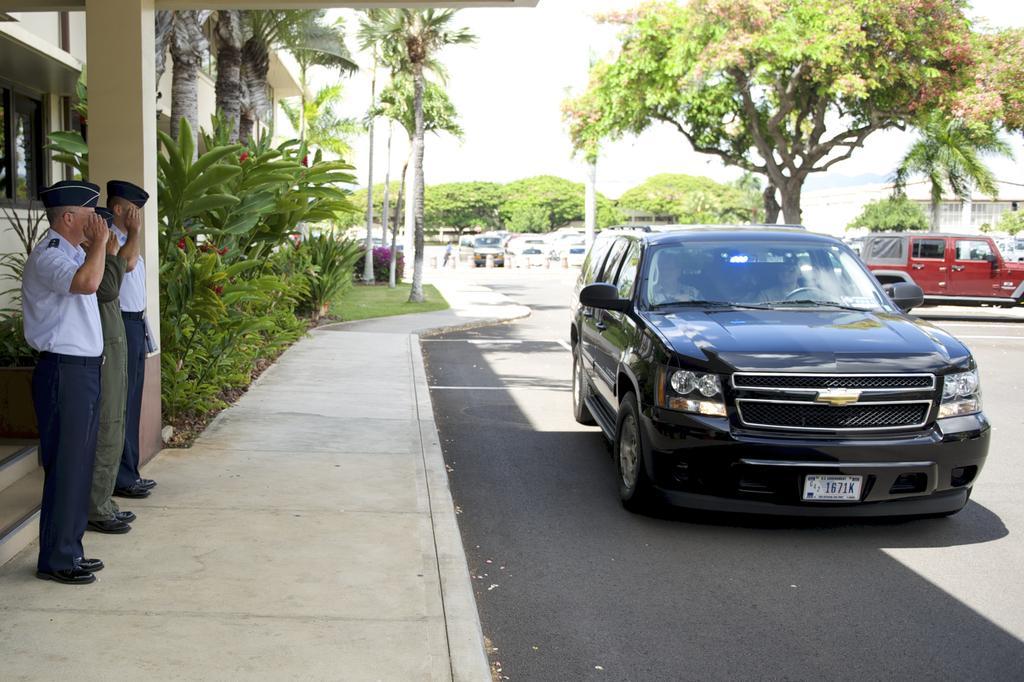Please provide a concise description of this image. This is outside a building. There is a car. In the left side we can see three people in uniform. Beside them there is a pillar. There are many trees in the left side. In the background also there are many trees. There are many cars in the background. The sky is sunny. There is a building in the left side. 